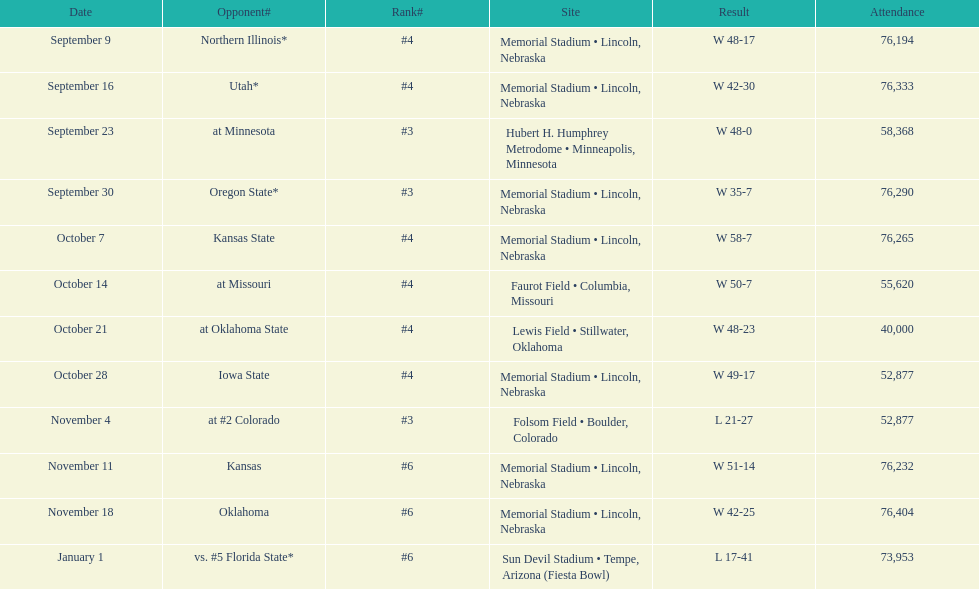How many matches did they win by over 7? 10. 